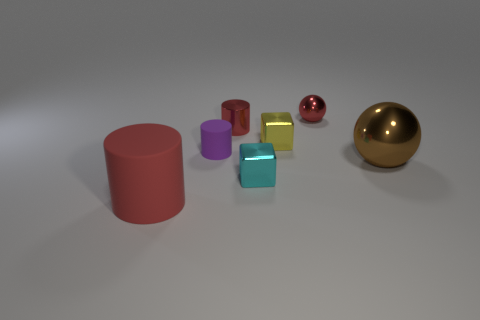Add 1 big purple shiny cubes. How many objects exist? 8 Subtract all spheres. How many objects are left? 5 Add 4 tiny red cylinders. How many tiny red cylinders are left? 5 Add 7 brown spheres. How many brown spheres exist? 8 Subtract 0 blue spheres. How many objects are left? 7 Subtract all yellow metal things. Subtract all small cylinders. How many objects are left? 4 